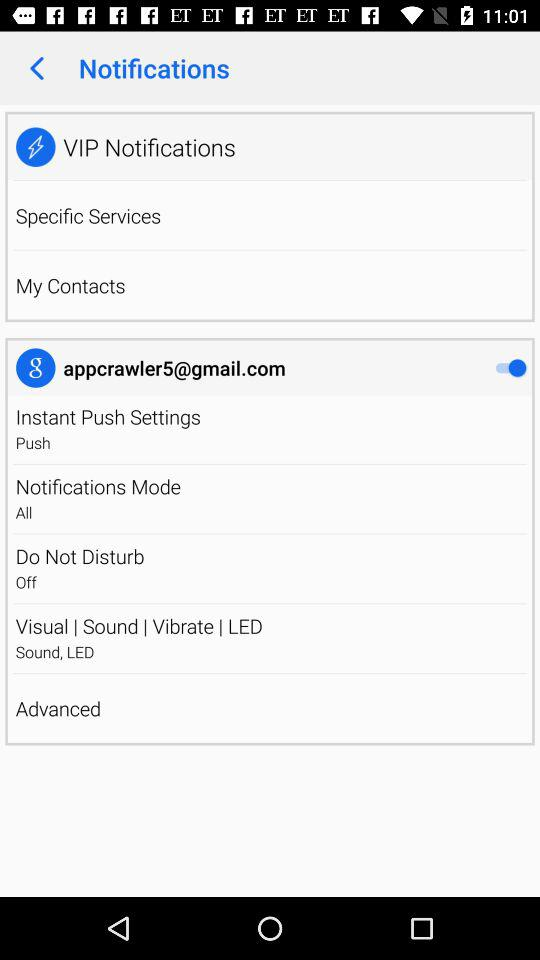What is the status of "Instant Push Settings"? The status of "Instant Push Settings" is "Push". 